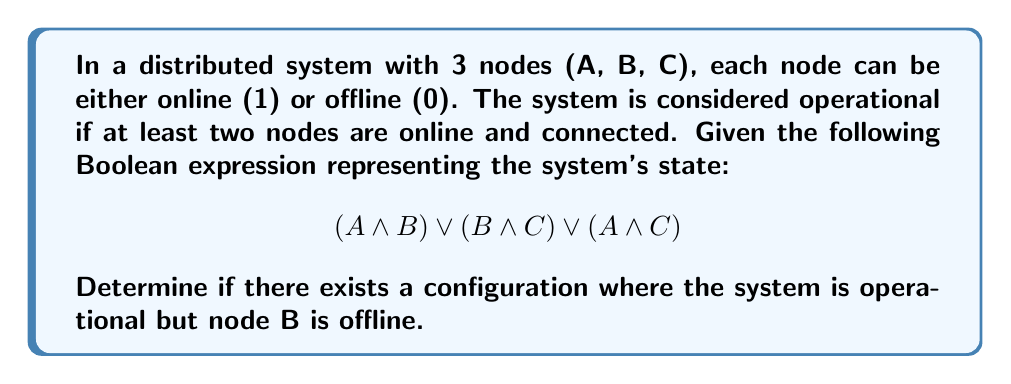Can you answer this question? Let's approach this step-by-step:

1) The given Boolean expression represents the system's operational state:
   $$(A \land B) \lor (B \land C) \lor (A \land C)$$

2) We want to find if there's a satisfiable configuration where the system is operational (expression is true) and B is offline (B = 0).

3) Let's substitute B = 0 into the expression:
   $$(A \land 0) \lor (0 \land C) \lor (A \land C)$$

4) Simplify:
   $$0 \lor 0 \lor (A \land C)$$

5) This reduces to:
   $$A \land C$$

6) For the system to be operational with B offline, we need both A and C to be online (1).

7) Let's check if this satisfies the original condition:
   - A = 1, B = 0, C = 1
   
8) Substituting these values into the original expression:
   $$(1 \land 0) \lor (0 \land 1) \lor (1 \land 1)$$
   $$= 0 \lor 0 \lor 1$$
   $$= 1$$

9) The expression evaluates to true, which means the system is operational.

Therefore, there exists a configuration where the system is operational but node B is offline, specifically when A and C are online and B is offline.
Answer: Yes 